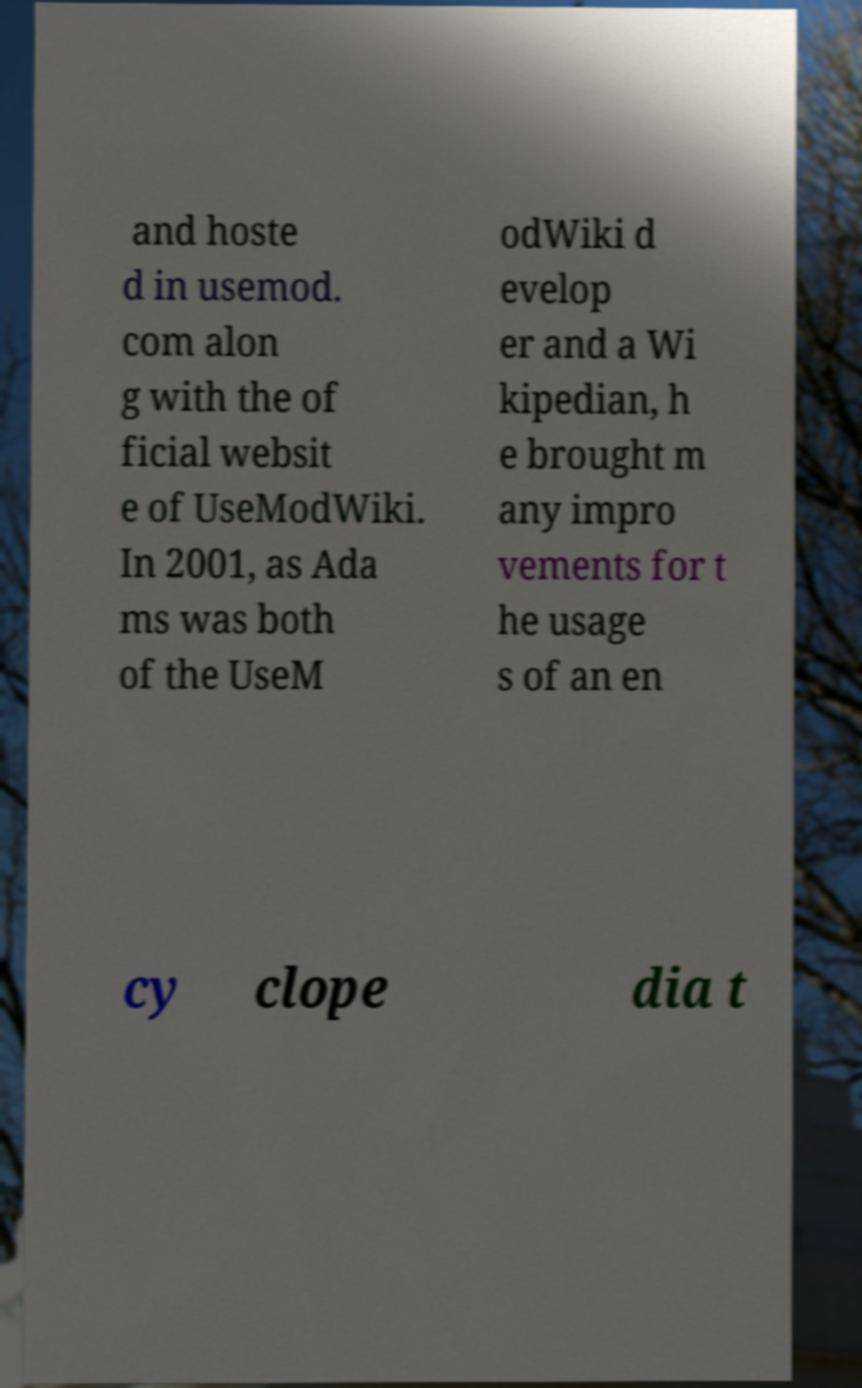Please identify and transcribe the text found in this image. and hoste d in usemod. com alon g with the of ficial websit e of UseModWiki. In 2001, as Ada ms was both of the UseM odWiki d evelop er and a Wi kipedian, h e brought m any impro vements for t he usage s of an en cy clope dia t 